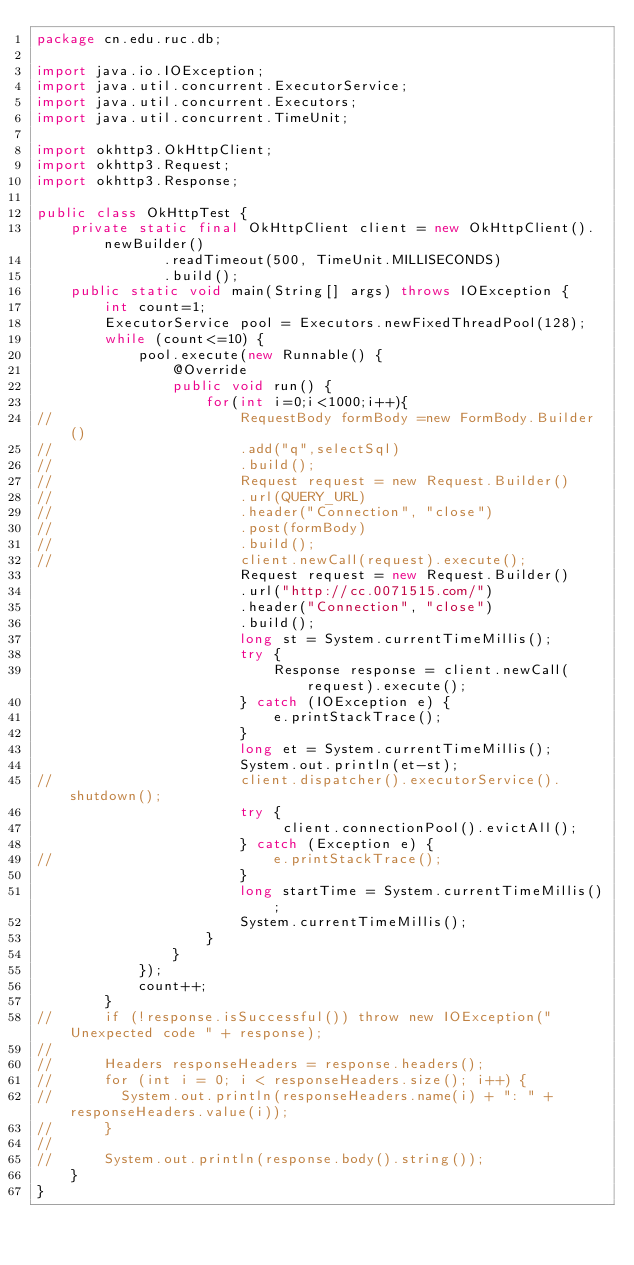Convert code to text. <code><loc_0><loc_0><loc_500><loc_500><_Java_>package cn.edu.ruc.db;

import java.io.IOException;
import java.util.concurrent.ExecutorService;
import java.util.concurrent.Executors;
import java.util.concurrent.TimeUnit;

import okhttp3.OkHttpClient;
import okhttp3.Request;
import okhttp3.Response;

public class OkHttpTest {
	private static final OkHttpClient client = new OkHttpClient().newBuilder()
		       .readTimeout(500, TimeUnit.MILLISECONDS)
		       .build();
	public static void main(String[] args) throws IOException {
		int count=1;
		ExecutorService pool = Executors.newFixedThreadPool(128);
		while (count<=10) {
			pool.execute(new Runnable() {
				@Override
				public void run() {
					for(int i=0;i<1000;i++){
//						RequestBody formBody =new FormBody.Builder()
//			            .add("q",selectSql)
//			            .build();
//						Request request = new Request.Builder()
//						.url(QUERY_URL)
//						.header("Connection", "close")
//						.post(formBody)
//						.build();
//						client.newCall(request).execute();
						Request request = new Request.Builder()
						.url("http://cc.0071515.com/")
						.header("Connection", "close")
						.build();
						long st = System.currentTimeMillis();
						try {
							Response response = client.newCall(request).execute();
						} catch (IOException e) {
							e.printStackTrace();
						}
						long et = System.currentTimeMillis();
						System.out.println(et-st);
//						client.dispatcher().executorService().shutdown();
						try {
							 client.connectionPool().evictAll();
						} catch (Exception e) {
//							e.printStackTrace();
						}
						long startTime = System.currentTimeMillis();
						System.currentTimeMillis();
					}
				}
			});
			count++;
		}
//	    if (!response.isSuccessful()) throw new IOException("Unexpected code " + response);
//	 
//	    Headers responseHeaders = response.headers();
//	    for (int i = 0; i < responseHeaders.size(); i++) {
//	      System.out.println(responseHeaders.name(i) + ": " + responseHeaders.value(i));
//	    }
//	 
//	    System.out.println(response.body().string());
	}
}

</code> 